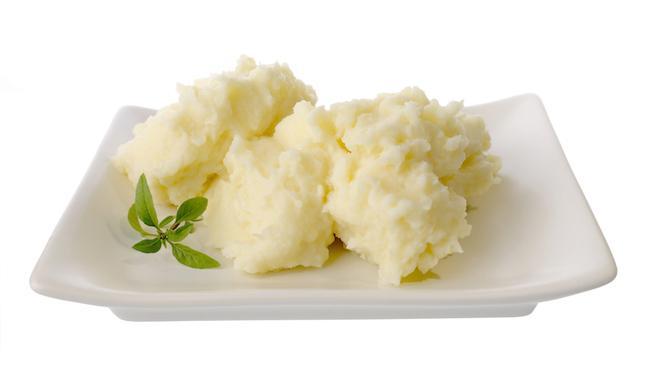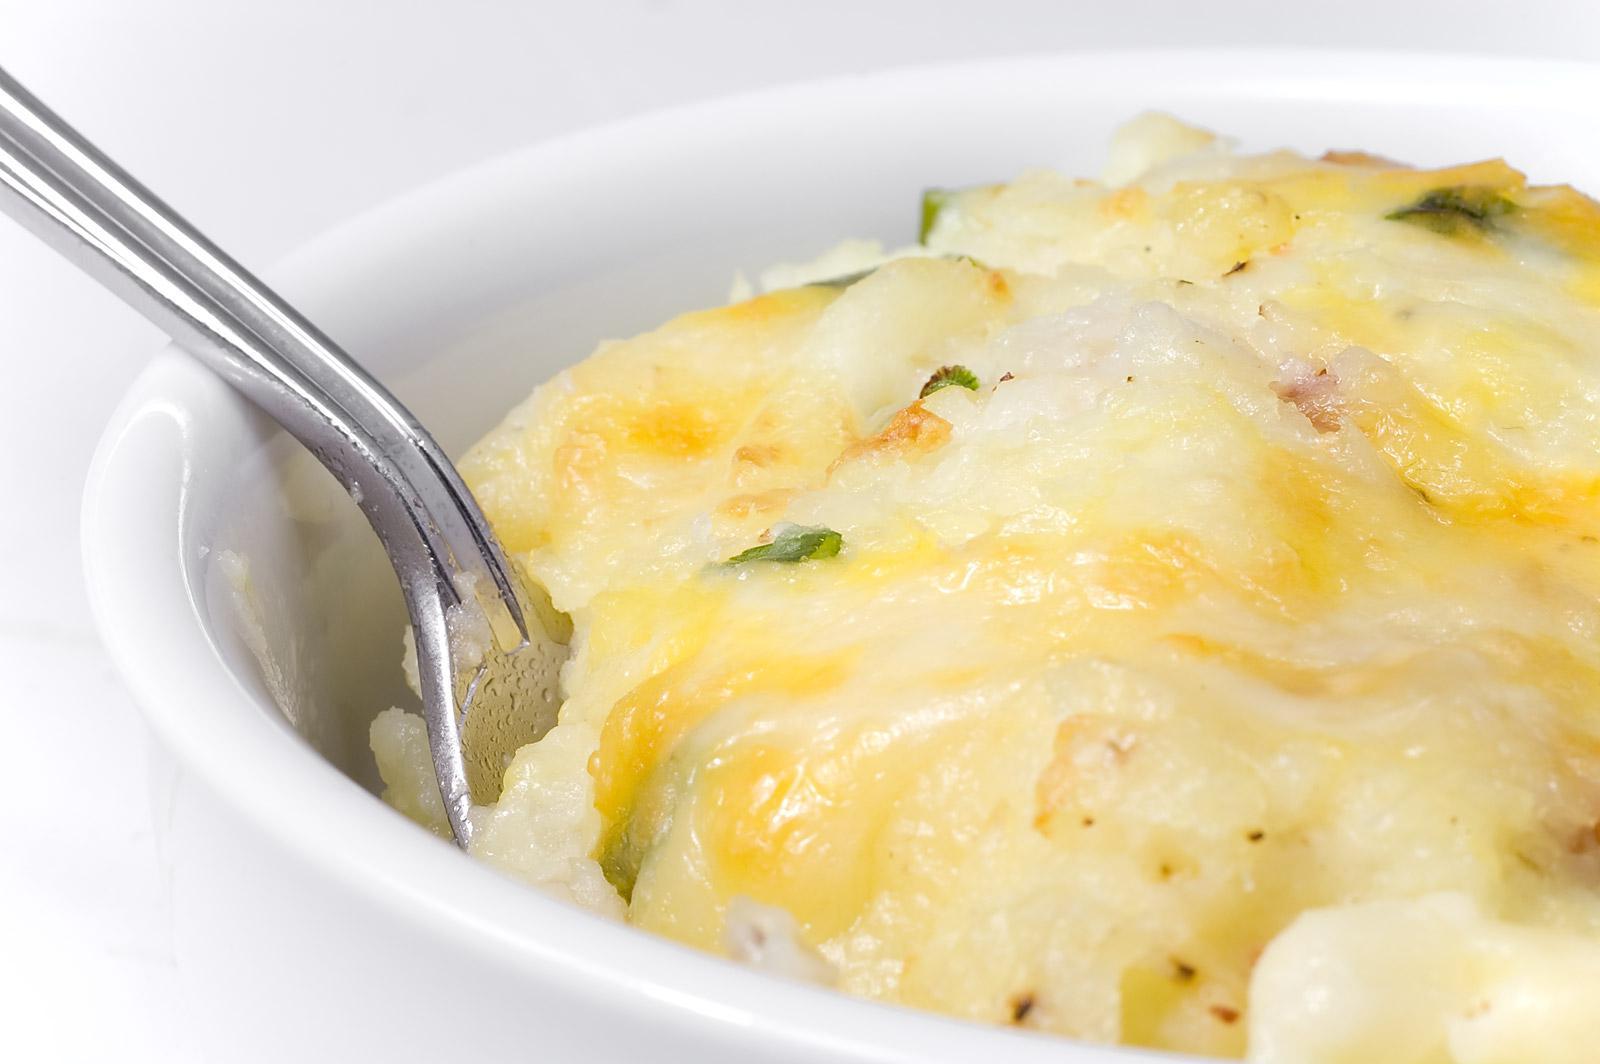The first image is the image on the left, the second image is the image on the right. Analyze the images presented: Is the assertion "There is a white plate of mashed potatoes and gravy in the image on the left." valid? Answer yes or no. No. The first image is the image on the left, the second image is the image on the right. Examine the images to the left and right. Is the description "One of the dishes of potatoes has a utensil stuck into the food." accurate? Answer yes or no. Yes. 